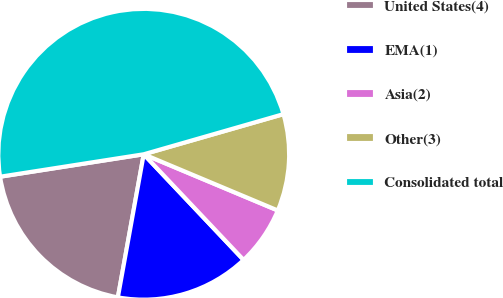<chart> <loc_0><loc_0><loc_500><loc_500><pie_chart><fcel>United States(4)<fcel>EMA(1)<fcel>Asia(2)<fcel>Other(3)<fcel>Consolidated total<nl><fcel>19.69%<fcel>14.9%<fcel>6.63%<fcel>10.77%<fcel>48.02%<nl></chart> 